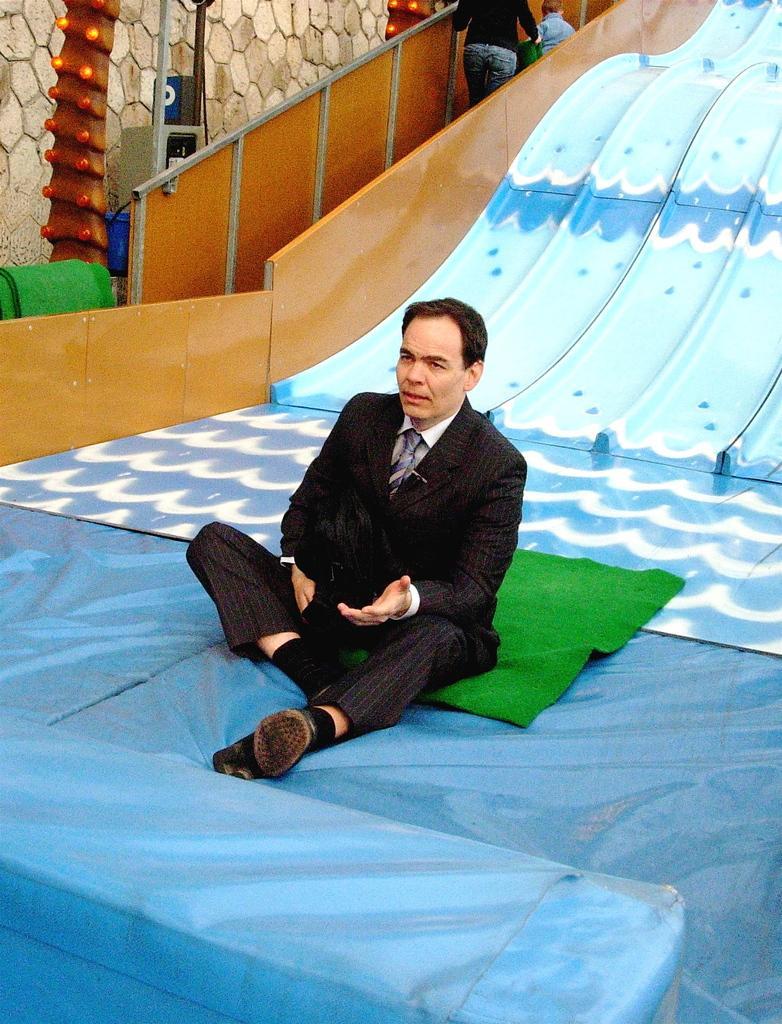Describe this image in one or two sentences. Here we can see a sheet, green carpets, railings, slides,bulbs, poles, wall and signboard. In this image we can see two people and one kid. This man is sitting on a green carpet. 